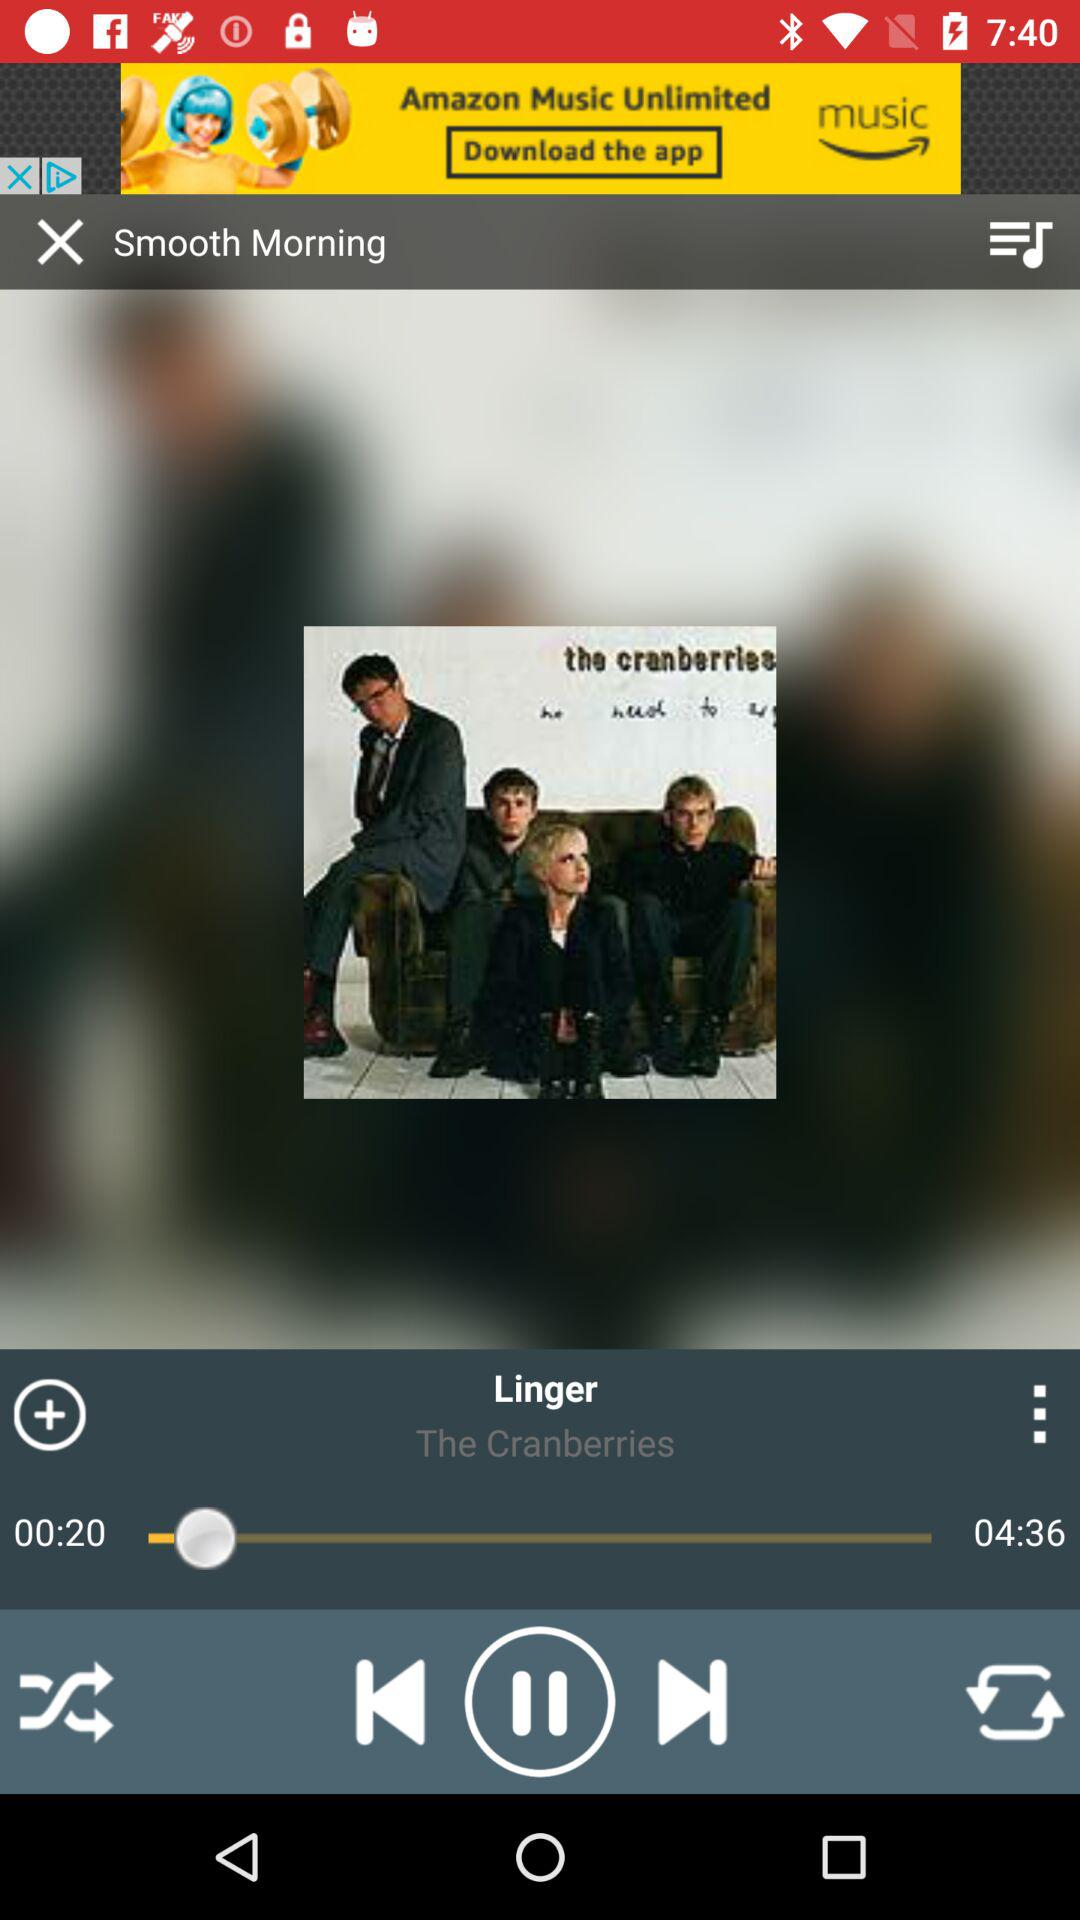What is the song's duration? The duration of the song is 4 minutes and 36 seconds. 